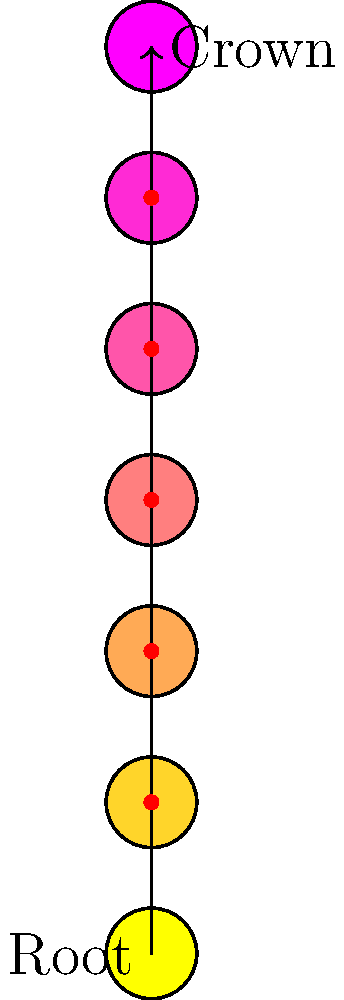Visualize the flow of energy through the seven main chakras, starting from the Root chakra at the base of the spine and moving upwards to the Crown chakra at the top of the head. If the energy moves through three intermediate chakras before reaching the Heart chakra, which is the central point, how many chakras remain to be activated before reaching the Crown chakra? To solve this problem, let's follow these steps:

1. Understand the chakra system:
   - There are seven main chakras aligned along the spine.
   - The chakras, from bottom to top, are: Root, Sacral, Solar Plexus, Heart, Throat, Third Eye, and Crown.

2. Identify the starting point:
   - The energy flow begins at the Root chakra (base of the spine).

3. Count the chakras up to the Heart chakra:
   - Root (start) → Sacral → Solar Plexus → Heart
   - This means we've passed through 3 intermediate chakras (Sacral, Solar Plexus, and Heart itself).

4. Identify the remaining chakras:
   - After the Heart chakra, we have: Throat → Third Eye → Crown

5. Count the remaining chakras:
   - There are 3 chakras left to activate: Throat, Third Eye, and Crown.

Therefore, after reaching the Heart chakra, there are 3 chakras remaining to be activated before reaching the Crown chakra.
Answer: 3 